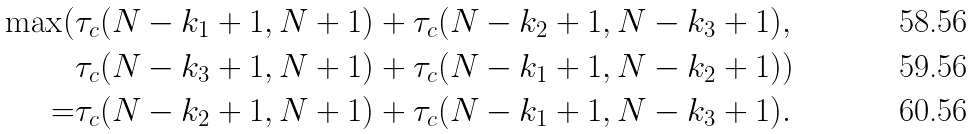Convert formula to latex. <formula><loc_0><loc_0><loc_500><loc_500>\max ( & \tau _ { c } ( N - k _ { 1 } + 1 , N + 1 ) + \tau _ { c } ( N - k _ { 2 } + 1 , N - k _ { 3 } + 1 ) , \\ & \tau _ { c } ( N - k _ { 3 } + 1 , N + 1 ) + \tau _ { c } ( N - k _ { 1 } + 1 , N - k _ { 2 } + 1 ) ) \\ = & \tau _ { c } ( N - k _ { 2 } + 1 , N + 1 ) + \tau _ { c } ( N - k _ { 1 } + 1 , N - k _ { 3 } + 1 ) .</formula> 